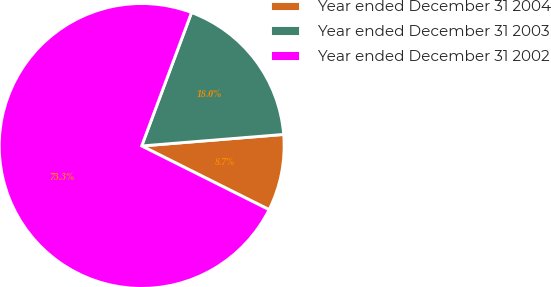Convert chart. <chart><loc_0><loc_0><loc_500><loc_500><pie_chart><fcel>Year ended December 31 2004<fcel>Year ended December 31 2003<fcel>Year ended December 31 2002<nl><fcel>8.67%<fcel>18.02%<fcel>73.31%<nl></chart> 